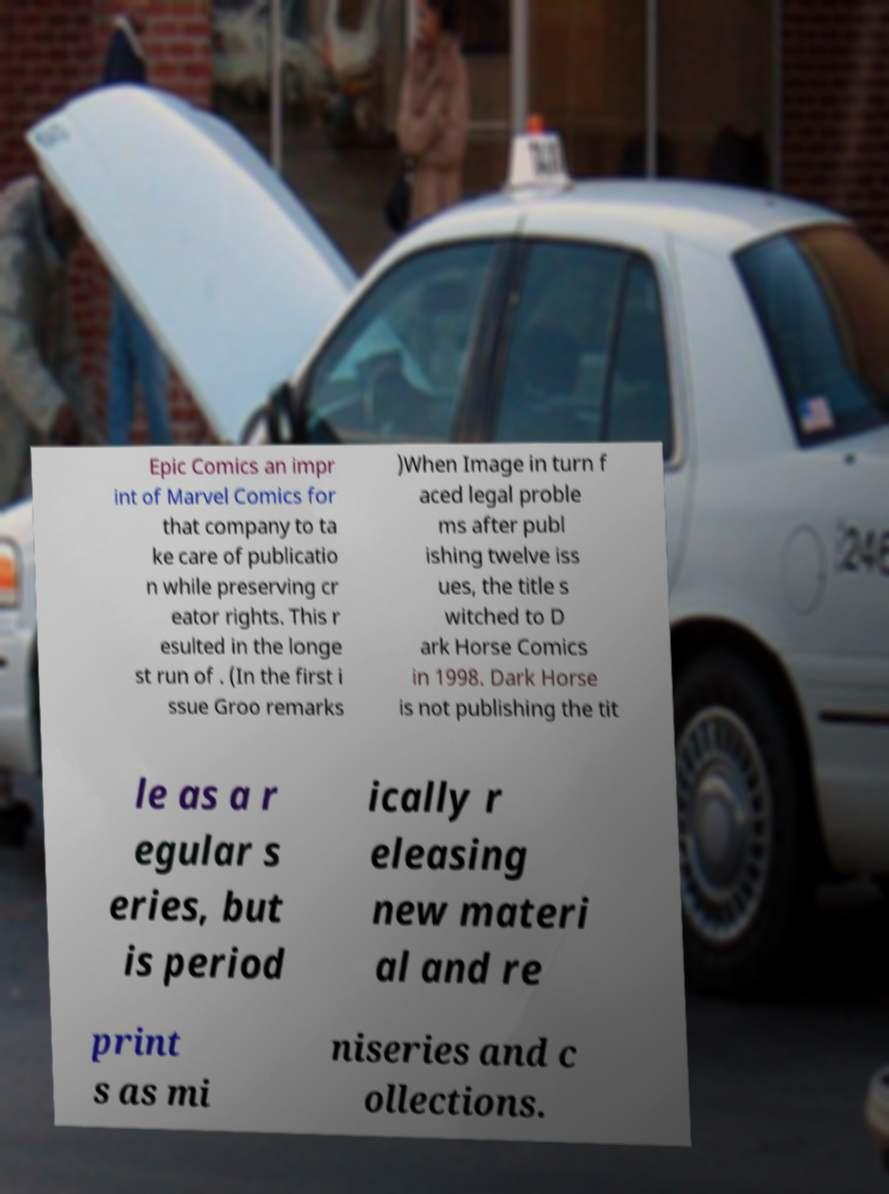I need the written content from this picture converted into text. Can you do that? Epic Comics an impr int of Marvel Comics for that company to ta ke care of publicatio n while preserving cr eator rights. This r esulted in the longe st run of . (In the first i ssue Groo remarks )When Image in turn f aced legal proble ms after publ ishing twelve iss ues, the title s witched to D ark Horse Comics in 1998. Dark Horse is not publishing the tit le as a r egular s eries, but is period ically r eleasing new materi al and re print s as mi niseries and c ollections. 